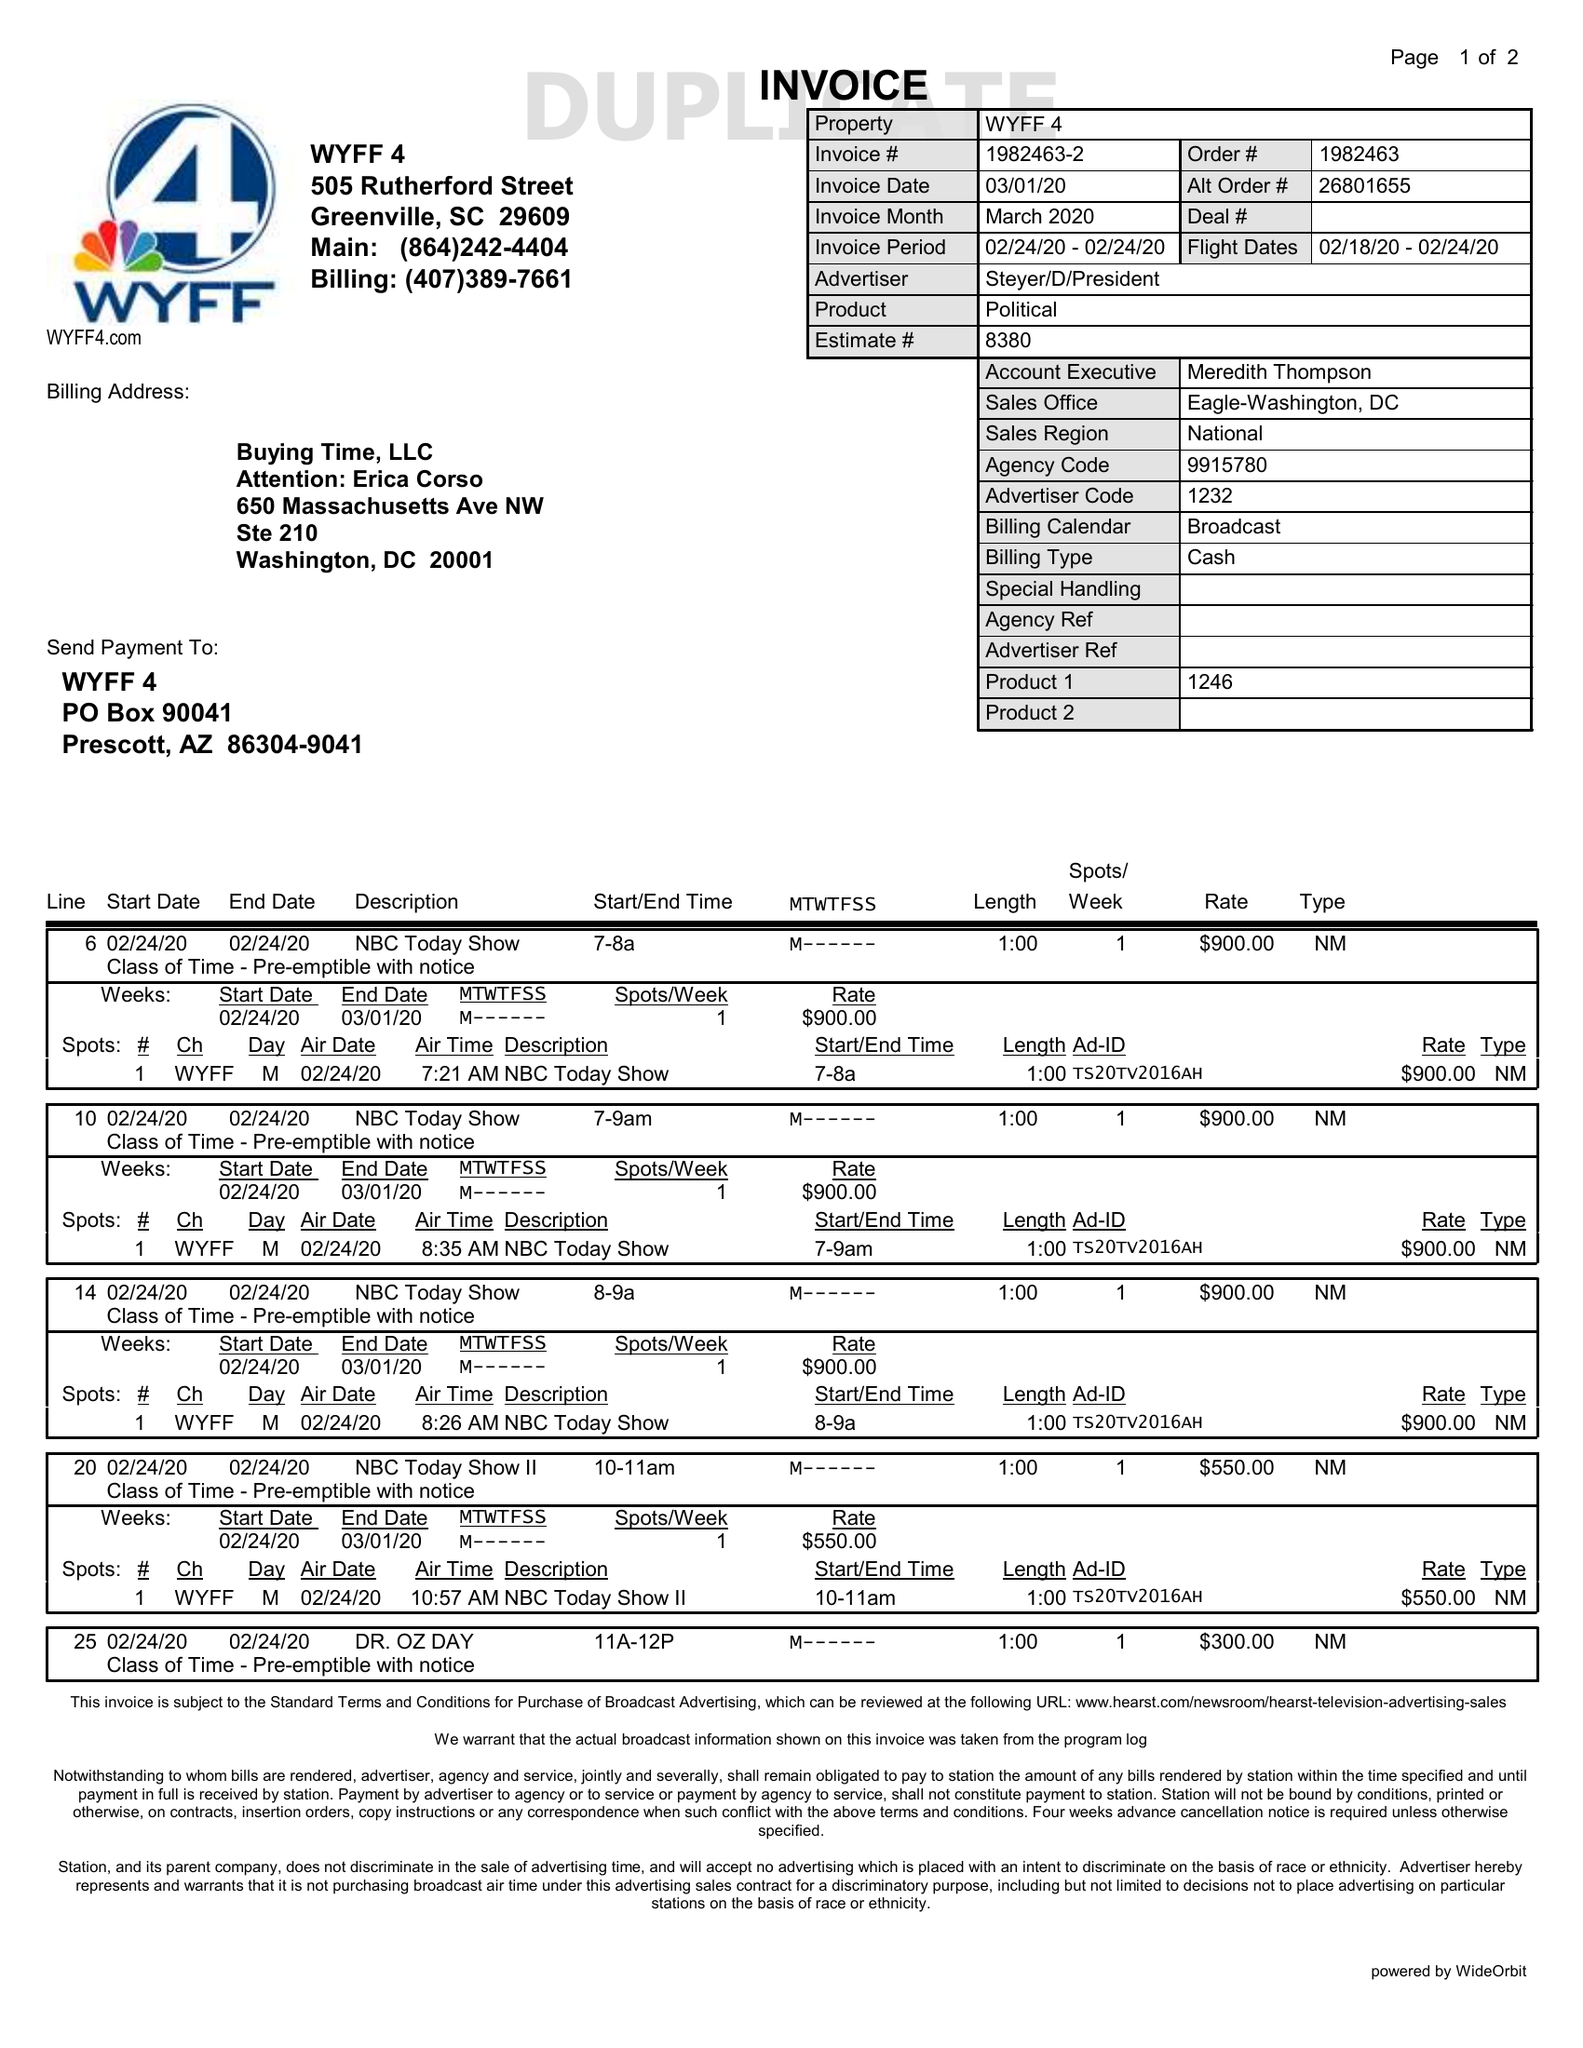What is the value for the flight_from?
Answer the question using a single word or phrase. 02/18/20 